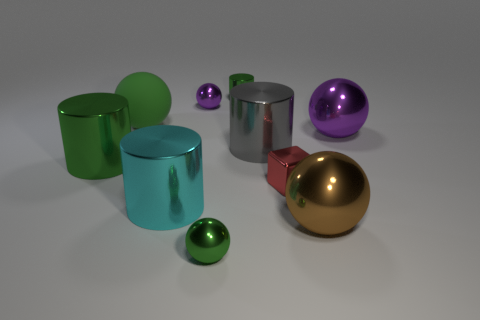Is there any other thing that is made of the same material as the big green sphere?
Offer a very short reply. No. What material is the green sphere left of the large cyan thing?
Give a very brief answer. Rubber. What color is the tiny sphere to the right of the small metal sphere that is behind the tiny object in front of the large cyan metal cylinder?
Your response must be concise. Green. The rubber sphere that is the same size as the cyan metal cylinder is what color?
Keep it short and to the point. Green. How many rubber objects are small objects or cylinders?
Your answer should be compact. 0. The small block that is the same material as the cyan object is what color?
Keep it short and to the point. Red. There is a small sphere left of the small green metal object that is in front of the brown metallic ball; what is it made of?
Make the answer very short. Metal. How many things are large purple shiny spheres that are on the right side of the big gray cylinder or purple shiny things that are in front of the large green rubber object?
Offer a terse response. 1. What size is the green metallic sphere left of the large brown ball that is in front of the cylinder that is behind the large purple sphere?
Your answer should be compact. Small. Are there an equal number of tiny purple shiny spheres that are in front of the large green cylinder and small green balls?
Your answer should be compact. No. 